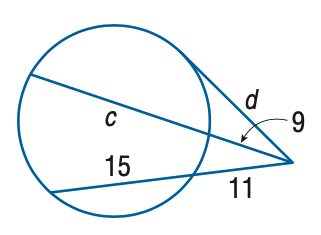Answer the mathemtical geometry problem and directly provide the correct option letter.
Question: Find the variable of c to the nearest tenth. Assume that segments that appear to be tangent are tangent.
Choices: A: 22.8 B: 23.8 C: 24.8 D: 25.8 A 